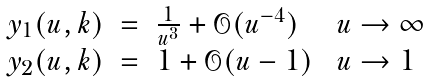<formula> <loc_0><loc_0><loc_500><loc_500>\begin{array} { l c l l } y _ { 1 } ( u , k ) & = & \frac { 1 } { u ^ { 3 } } + \mathcal { O } ( u ^ { - 4 } ) \ & u \rightarrow \infty \\ y _ { 2 } ( u , k ) & = & 1 + \mathcal { O } ( u - 1 ) \ & u \rightarrow 1 \end{array}</formula> 